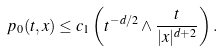Convert formula to latex. <formula><loc_0><loc_0><loc_500><loc_500>p _ { 0 } ( t , x ) \leq c _ { 1 } \left ( t ^ { - d / 2 } \wedge \frac { t } { | x | ^ { d + 2 } } \right ) .</formula> 